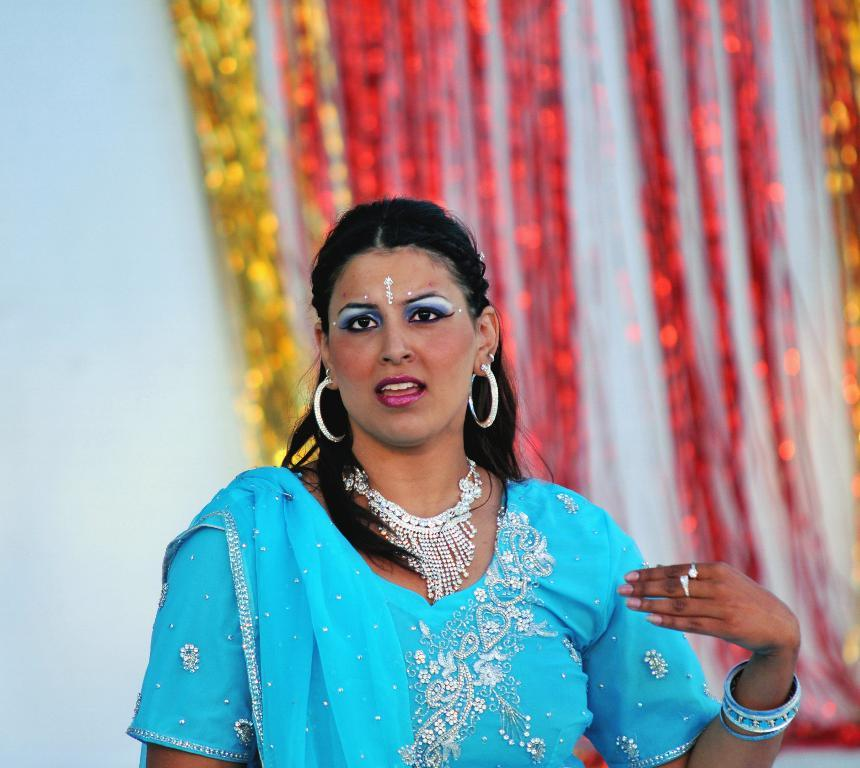Who or what is present in the image? There is a person in the image. What is the person wearing? The person is wearing a blue dress. What can be seen in the background of the image? There is a curtain and a wall in the background of the image. How many horses are visible in the image? There are no horses present in the image; it features a person wearing a blue dress with a curtain and a wall in the background. 